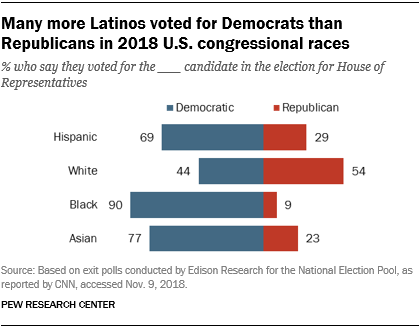Specify some key components in this picture. The value of the smallest red bar is 9. The difference between the largest blue bar value and the smallest red bar value is calculated, and the resulting value is compared to 90. The result is that the difference is less than or equal to 90. 